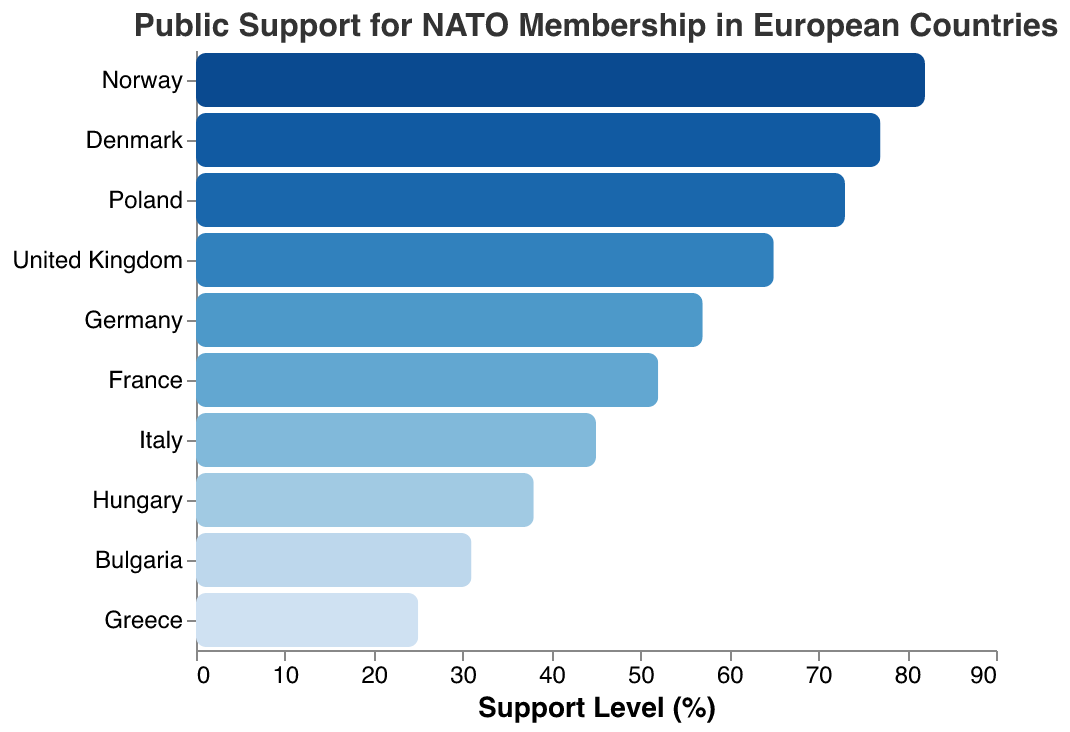What's the title of the figure? The title of the figure is located at the top center, written in a large font.
Answer: Public Support for NATO Membership in European Countries Which country has the highest support level for NATO membership? The country with the highest bar value on the x-axis corresponds to the highest support level.
Answer: Norway Compare the support levels between France and Italy. Which country has higher support for NATO, and by how much? From the figure, France has a 52% support level, and Italy has 45%. The difference is 52% - 45%.
Answer: France, 7% What's the average support level across all listed countries? Sum all percentages: (82 + 77 + 73 + 65 + 57 + 52 + 45 + 38 + 31 + 25) = 545. The average is 545 / 10.
Answer: 54.5% Between Germany and Poland, which country has less support for NATO membership? Compare their support levels; Germany has 57% and Poland has 73%.
Answer: Germany How many countries have a support level lower than 50%? Count the countries with support levels below 50%: Italy, Hungary, Bulgaria, and Greece, making it 4 countries.
Answer: 4 Which country has the closest support level to the average support level of all countries? The average support level is 54.5%. Scan through the support levels to find the closest to 54.5%, which is 52% (France).
Answer: France What percentage of countries have support levels above 60%? There are 5 countries above 60% support (Norway, Denmark, Poland, United Kingdom, and Germany). So the percentage is (5/10)*100.
Answer: 50% What is the difference in support levels between the country with the highest support and the country with the lowest support? The highest support is 82% (Norway), and the lowest is 25% (Greece). The difference is 82% - 25%.
Answer: 57% 